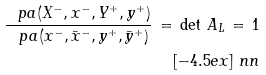<formula> <loc_0><loc_0><loc_500><loc_500>\frac { \ p a ( X ^ { - } , x ^ { - } , Y ^ { + } , y ^ { + } ) } { \ p a ( x ^ { - } , { \bar { x } } ^ { - } , y ^ { + } , { \bar { y } } ^ { + } ) } \, = \, \det \, { A } _ { L } \, = \, 1 \\ [ - 4 . 5 e x ] \ n n</formula> 